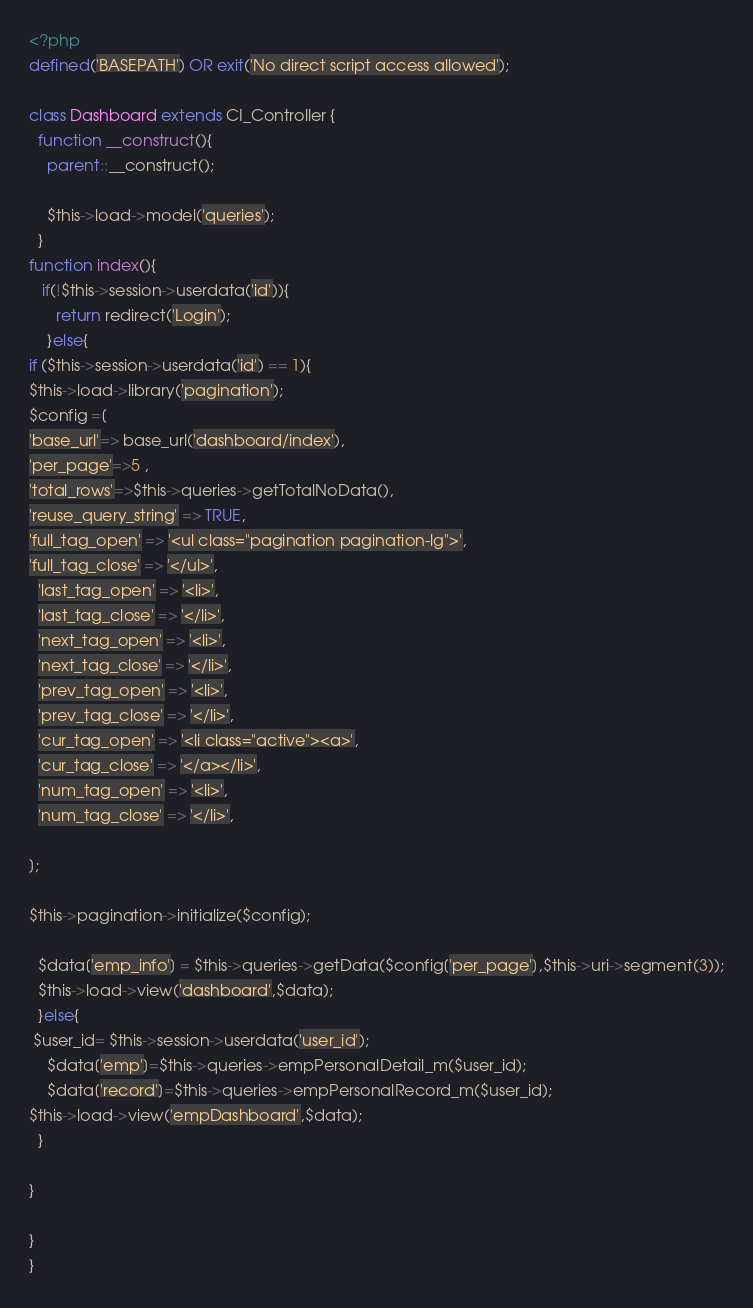<code> <loc_0><loc_0><loc_500><loc_500><_PHP_><?php
defined('BASEPATH') OR exit('No direct script access allowed');

class Dashboard extends CI_Controller {
  function __construct(){
    parent::__construct();
   
    $this->load->model('queries');
  }
function index(){
   if(!$this->session->userdata('id')){
      return redirect('Login');
    }else{
if ($this->session->userdata('id') == 1){
$this->load->library('pagination');
$config =[
'base_url'=> base_url('dashboard/index'),
'per_page'=>5 ,
'total_rows'=>$this->queries->getTotalNoData(),
'reuse_query_string' => TRUE,
'full_tag_open' => '<ul class="pagination pagination-lg">',
'full_tag_close' => '</ul>',
  'last_tag_open' => '<li>',
  'last_tag_close' => '</li>',
  'next_tag_open' => '<li>',
  'next_tag_close' => '</li>',
  'prev_tag_open' => '<li>',
  'prev_tag_close' => '</li>',
  'cur_tag_open' => '<li class="active"><a>',
  'cur_tag_close' => '</a></li>',
  'num_tag_open' => '<li>',
  'num_tag_close' => '</li>',

];

$this->pagination->initialize($config);

  $data['emp_info'] = $this->queries->getData($config['per_page'],$this->uri->segment(3));
  $this->load->view('dashboard',$data);
  }else{
 $user_id= $this->session->userdata('user_id');
    $data['emp']=$this->queries->empPersonalDetail_m($user_id);
    $data['record']=$this->queries->empPersonalRecord_m($user_id);
$this->load->view('empDashboard',$data);
  }

}

}
}


</code> 